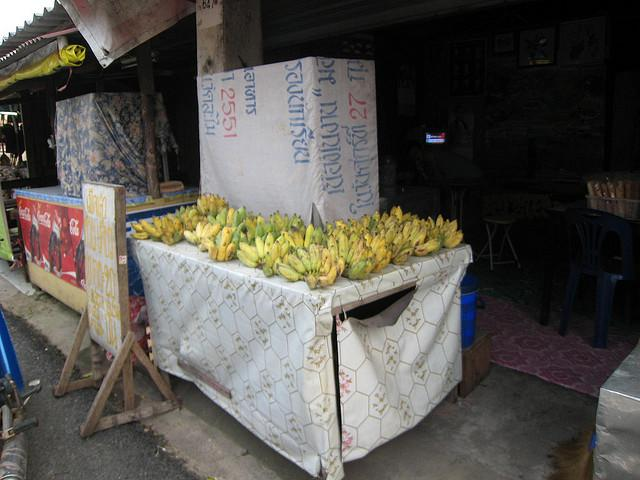What country produces a large number of these yellow food items? Please explain your reasoning. india. India produces these. 